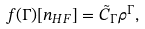<formula> <loc_0><loc_0><loc_500><loc_500>f ( \Gamma ) [ n _ { H F } ] = \tilde { C } _ { \Gamma } \rho ^ { \Gamma } ,</formula> 